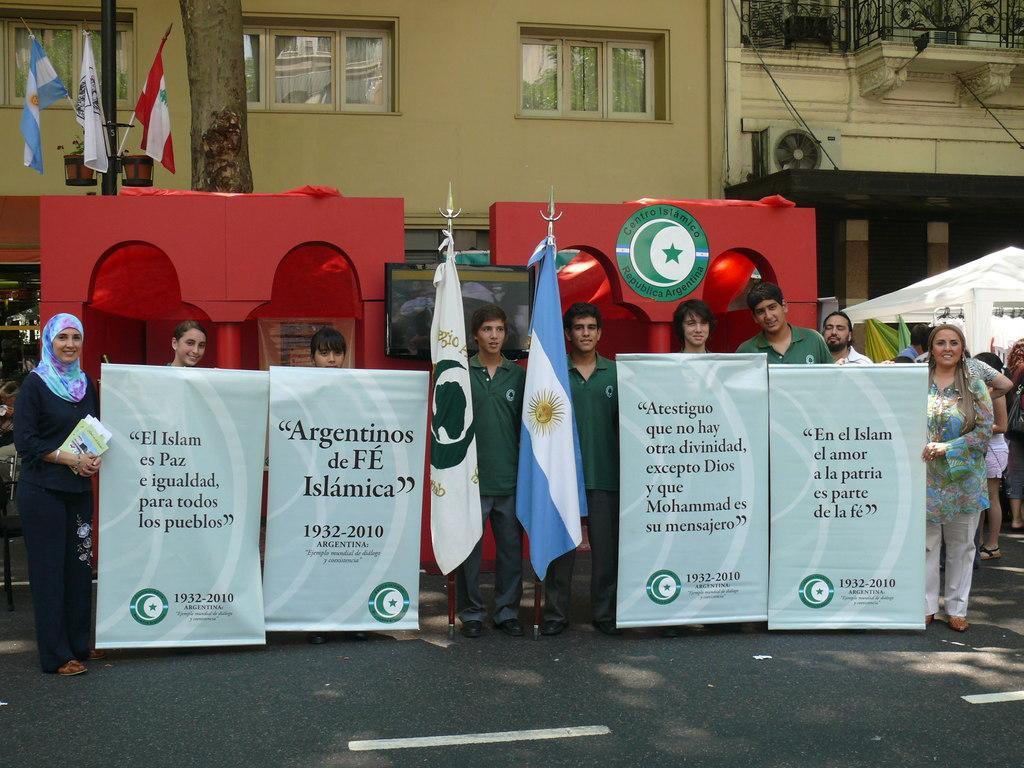Can you describe this image briefly? Here I can see few people are holding banners, flags in the hands, standing on the road, smiling and giving pose for the picture. At the back of these people there are few tents. In the background there is a building and a tree trunk. In the top left-hand corner there are few flags. 